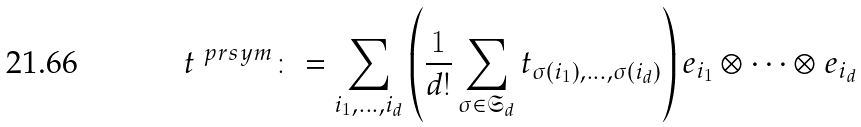<formula> <loc_0><loc_0><loc_500><loc_500>t ^ { \ p r s y m } \colon = \sum _ { i _ { 1 } , \dots , i _ { d } } \left ( \frac { 1 } { d ! } \sum _ { \sigma \in \mathfrak { S } _ { d } } t _ { \sigma ( i _ { 1 } ) , \dots , \sigma ( i _ { d } ) } \right ) e _ { i _ { 1 } } \otimes \cdots \otimes e _ { i _ { d } }</formula> 